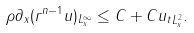<formula> <loc_0><loc_0><loc_500><loc_500>\| \rho \partial _ { x } ( r ^ { n - 1 } u ) \| _ { L ^ { \infty } _ { x } } \leq C + C \| u _ { t } \| _ { L ^ { 2 } _ { x } } .</formula> 